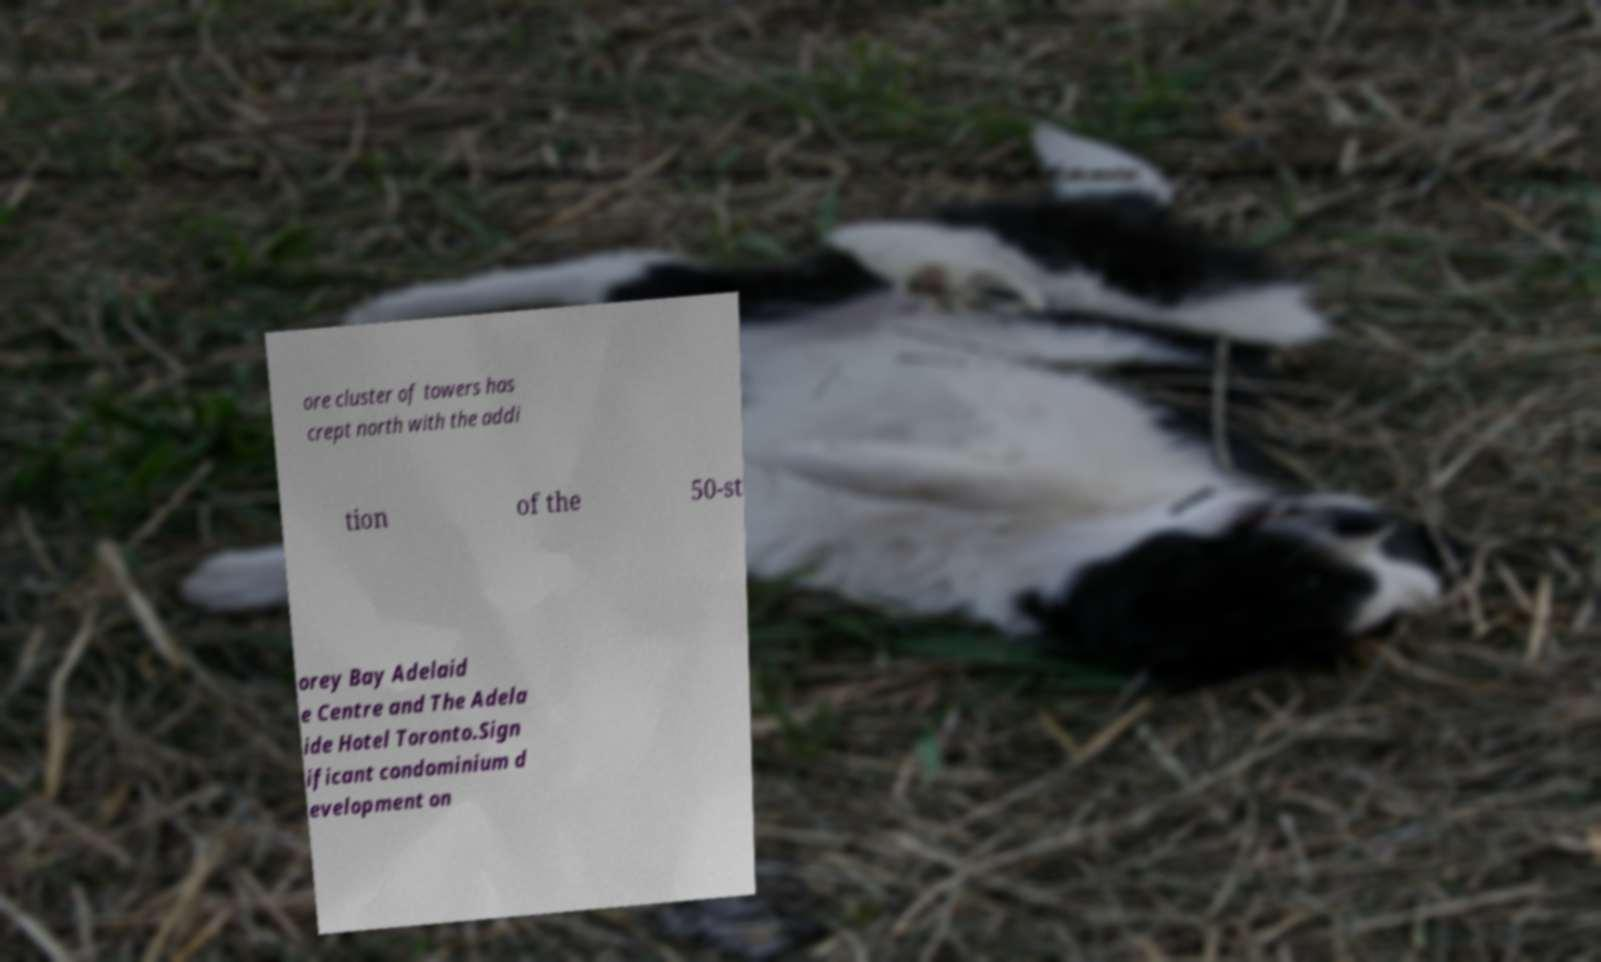Could you assist in decoding the text presented in this image and type it out clearly? ore cluster of towers has crept north with the addi tion of the 50-st orey Bay Adelaid e Centre and The Adela ide Hotel Toronto.Sign ificant condominium d evelopment on 